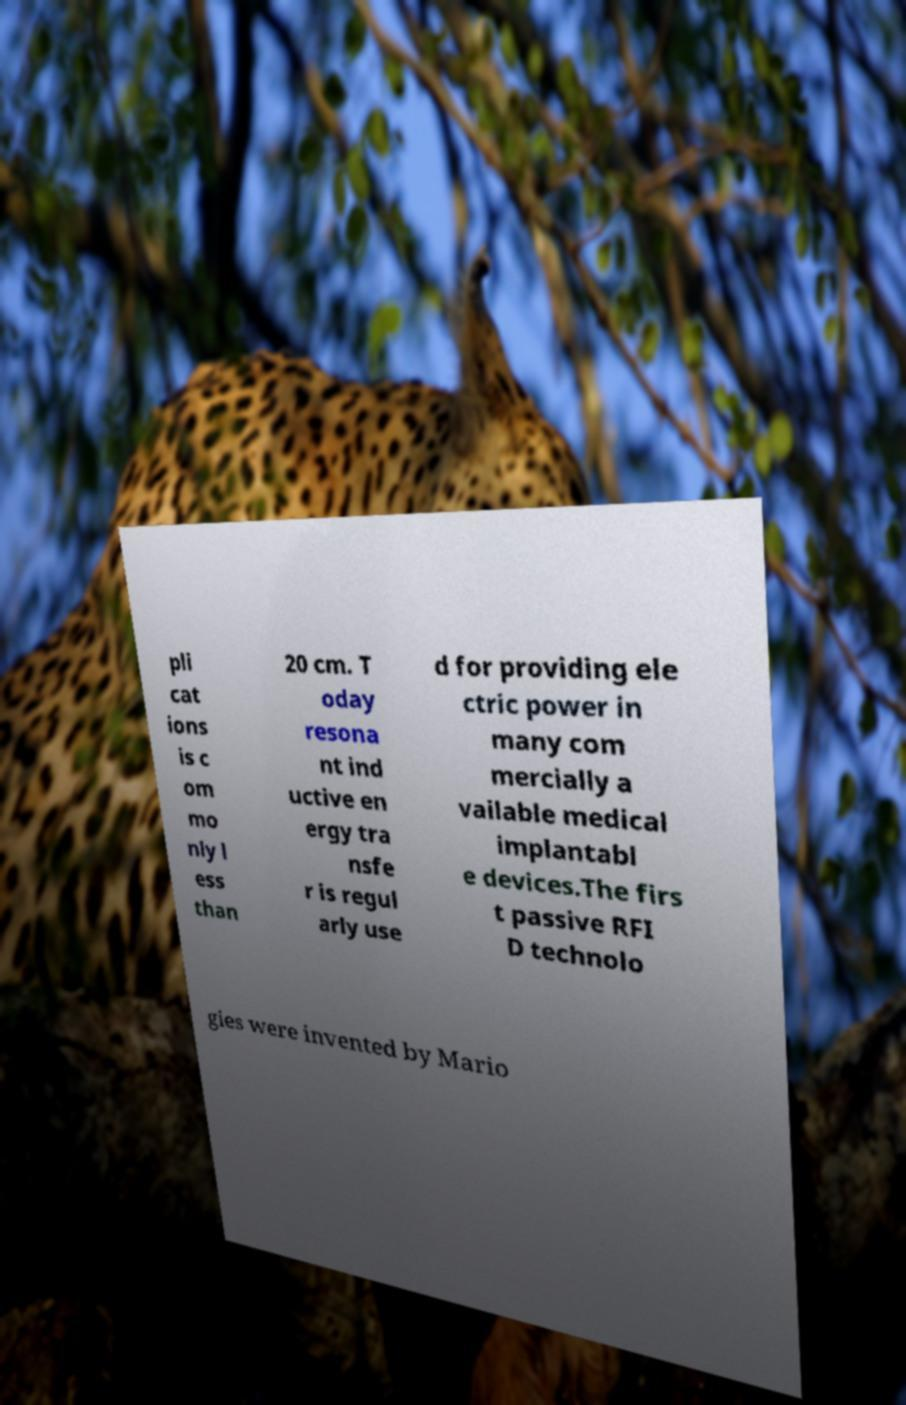Can you accurately transcribe the text from the provided image for me? pli cat ions is c om mo nly l ess than 20 cm. T oday resona nt ind uctive en ergy tra nsfe r is regul arly use d for providing ele ctric power in many com mercially a vailable medical implantabl e devices.The firs t passive RFI D technolo gies were invented by Mario 